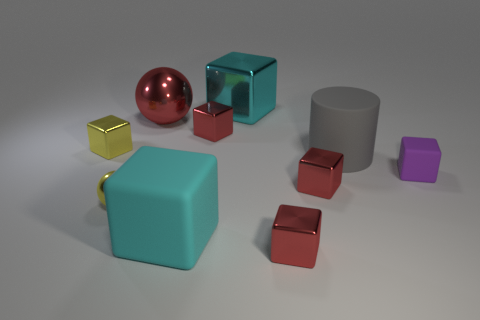Is the number of big red spheres that are in front of the big red metallic thing the same as the number of matte cubes?
Keep it short and to the point. No. Does the big cube in front of the big shiny block have the same color as the big metal object that is to the left of the big cyan metal object?
Keep it short and to the point. No. There is a big object that is both behind the small purple rubber cube and in front of the tiny yellow metallic cube; what is its material?
Provide a succinct answer. Rubber. The large cylinder is what color?
Your answer should be compact. Gray. What number of other things are the same shape as the large cyan rubber object?
Your answer should be compact. 6. Is the number of small metal spheres that are in front of the tiny yellow block the same as the number of large red balls that are behind the large cylinder?
Give a very brief answer. Yes. What is the small purple block made of?
Provide a short and direct response. Rubber. There is a red cube behind the big matte cylinder; what is it made of?
Keep it short and to the point. Metal. Are there any other things that have the same material as the red sphere?
Give a very brief answer. Yes. Are there more large cubes to the left of the tiny purple thing than large red matte balls?
Provide a succinct answer. Yes. 